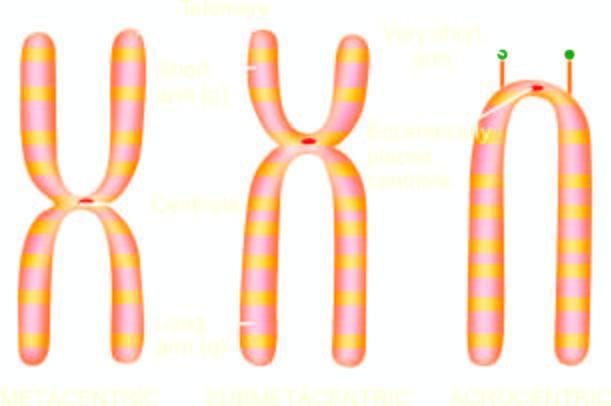what is classification of chromosomes based on?
Answer the question using a single word or phrase. Size and location centromere 